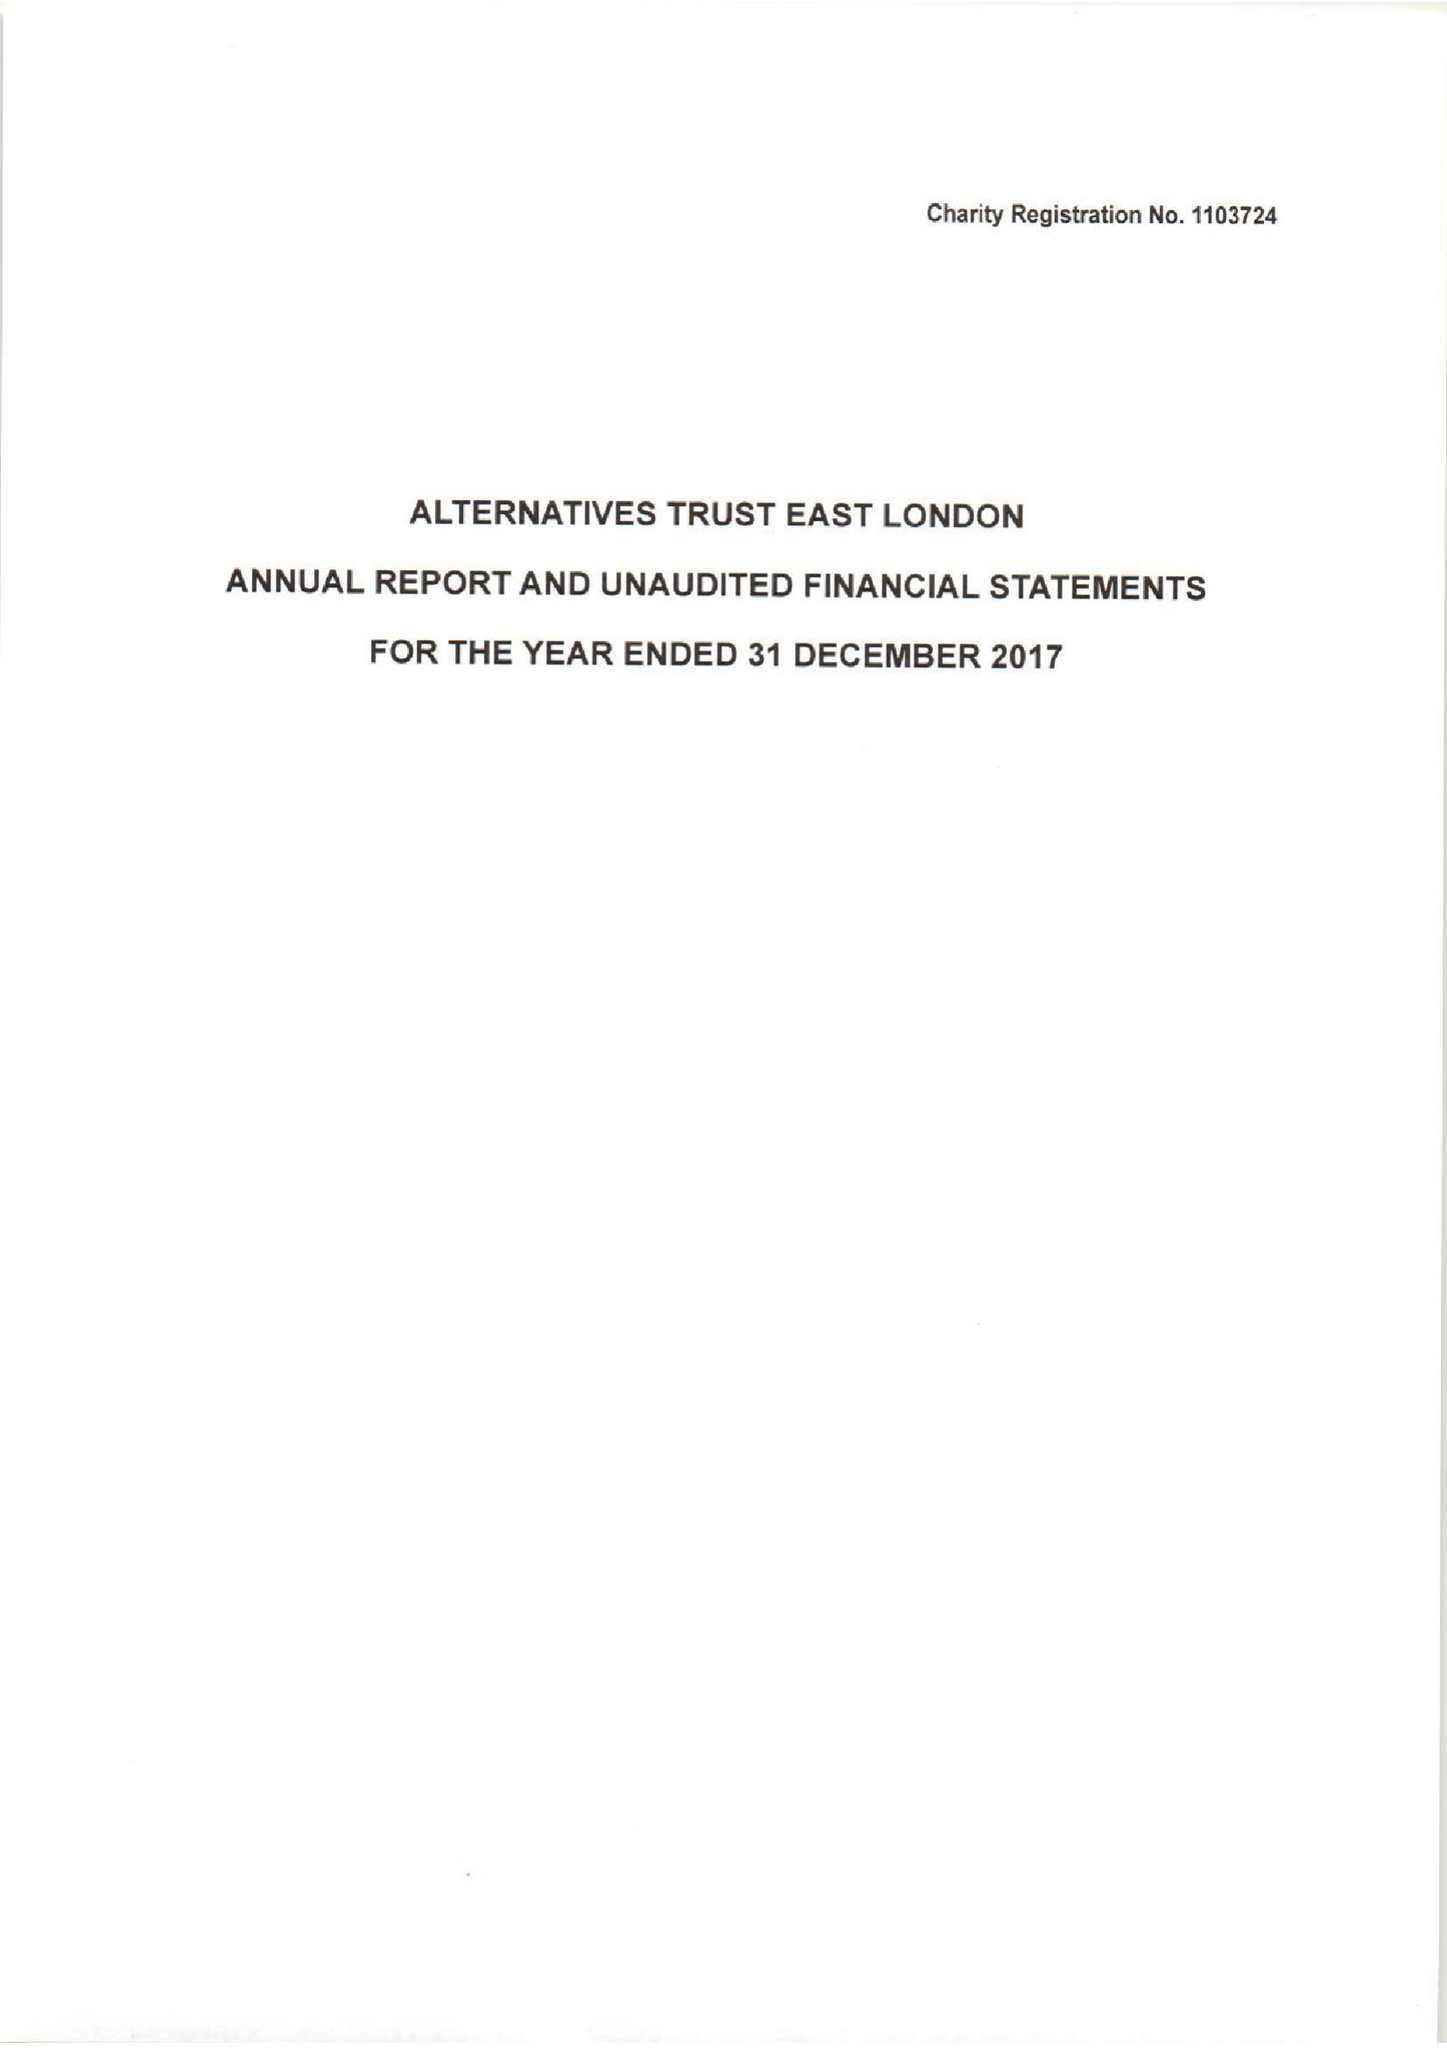What is the value for the address__post_town?
Answer the question using a single word or phrase. LONDON 